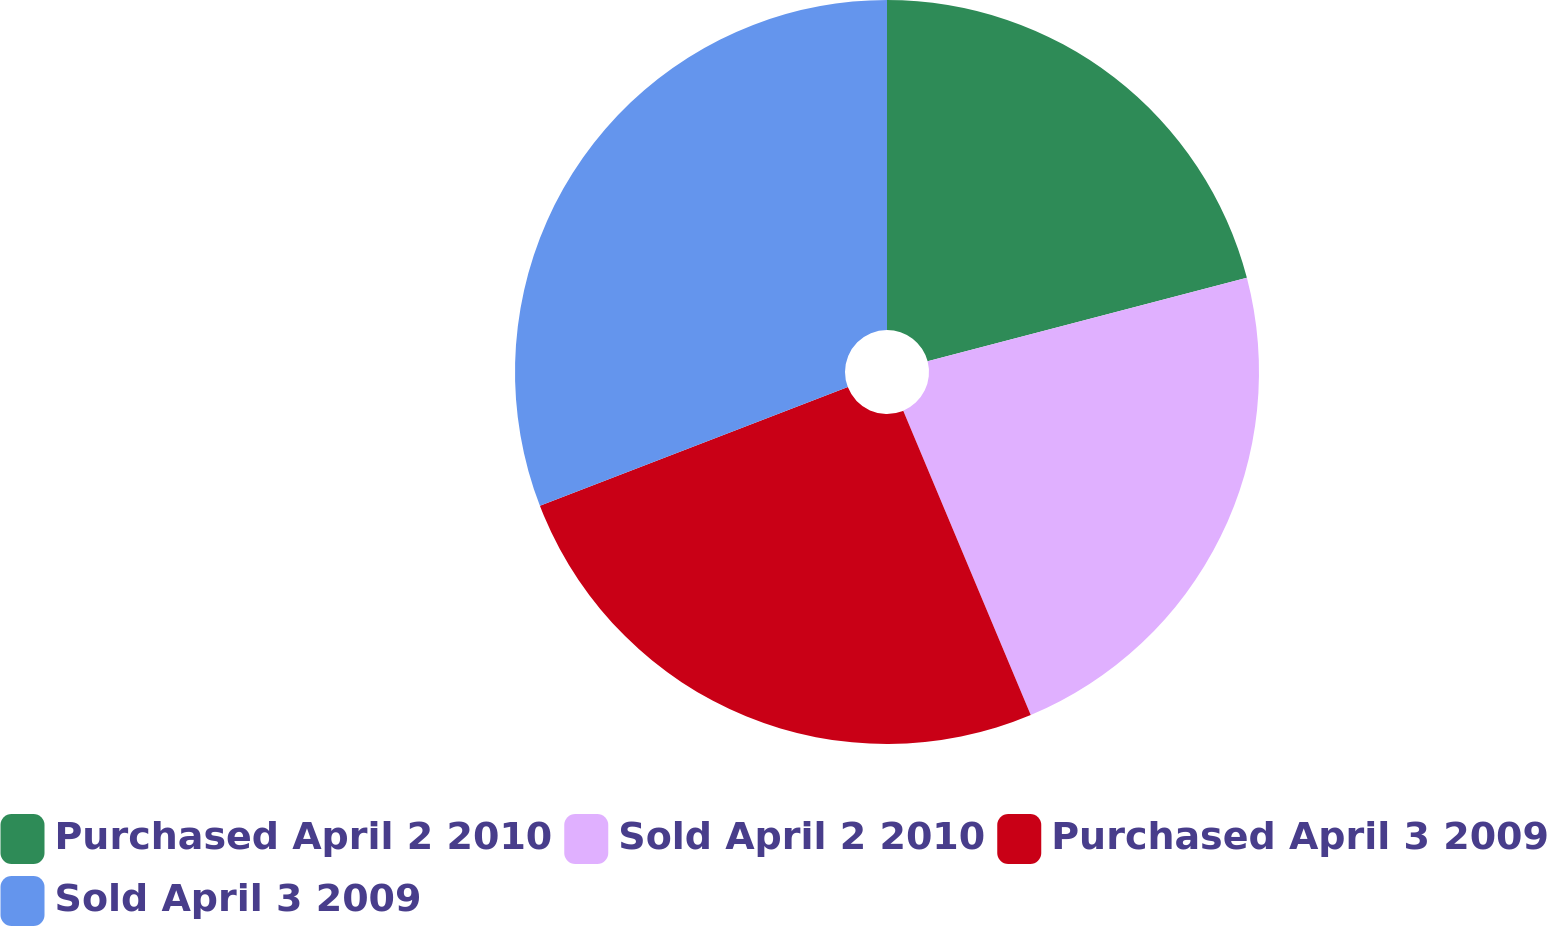Convert chart. <chart><loc_0><loc_0><loc_500><loc_500><pie_chart><fcel>Purchased April 2 2010<fcel>Sold April 2 2010<fcel>Purchased April 3 2009<fcel>Sold April 3 2009<nl><fcel>20.93%<fcel>22.76%<fcel>25.46%<fcel>30.86%<nl></chart> 